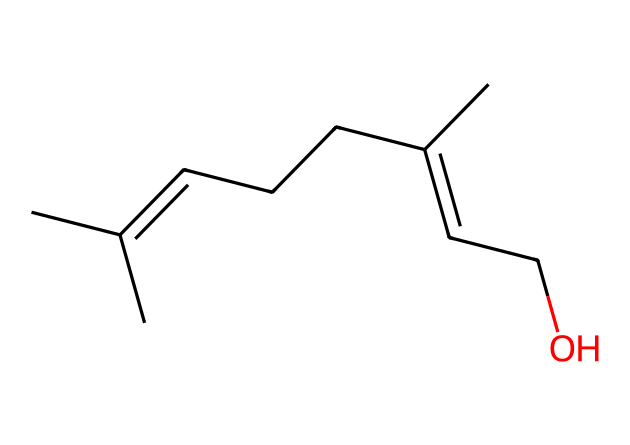What is the molecular formula of this compound? To find the molecular formula, we count the number of each type of atom present in the SMILES representation. This particular compound exhibits the elements carbon (C), hydrogen (H), and oxygen (O). Counting the atoms gives us C10, H18, O1, leading to the molecular formula C10H18O.
Answer: C10H18O How many carbon atoms are in this molecule? By examining the SMILES structure, we can see the representation includes 10 carbon atoms, which are denoted by the 'C' symbols.
Answer: 10 Does this molecule have any double bonds? In the SMILES, the '=' symbol indicates the presence of double bonds. By analyzing the structure, we identify that there are two double bonds in this molecule.
Answer: Yes What type of functional group is present in this compound? The presence of 'O' at the end of the SMILES indicates that there is an alcohol functional group, which is characterized by an -OH group. Thus, the functional group in this chemical is an alcohol.
Answer: alcohol How many hydrogen atoms are connected to the end carbon? The terminal carbon atom is connected to three hydrogen atoms, as indicated by its placement in the SMILES and typical bonding patterns where terminal carbons connect to more hydrogen atoms.
Answer: 3 What is the significance of the cyclic structure in aromatic compounds? Although this particular compound does not exhibit aromaticity due to lack of a benzene ring, the presence of cyclic structures in organic compounds often contributes to stability and distinct reactivity patterns, in contrast to linear structures.
Answer: Not applicable 